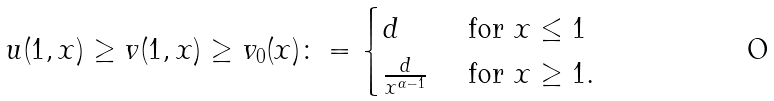<formula> <loc_0><loc_0><loc_500><loc_500>u ( 1 , x ) \geq v ( 1 , x ) \geq v _ { 0 } ( x ) \colon = \begin{cases} d & \text { for } x \leq 1 \\ \frac { d } { x ^ { \alpha - 1 } } & \text { for } x \geq 1 . \end{cases}</formula> 